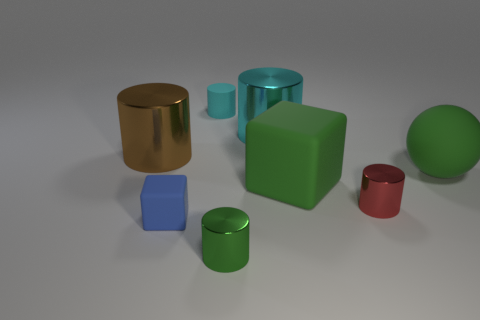Are any of the objects casting shadows, and if so, can you determine the light source direction? Each object in the image is casting a shadow, suggesting the light source is coming from the upper right corner of the image, given the angle and direction of the shadows.  Could you describe the texture of the surfaces on which the objects are resting? The surface appears to be smooth and even, with a slight diffuse reflection, indicating it may be a matte surface with a fine texture, not easily discernible from this distance. 